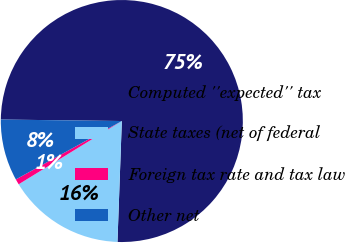Convert chart to OTSL. <chart><loc_0><loc_0><loc_500><loc_500><pie_chart><fcel>Computed ''expected'' tax<fcel>State taxes (net of federal<fcel>Foreign tax rate and tax law<fcel>Other net<nl><fcel>75.38%<fcel>15.67%<fcel>0.74%<fcel>8.21%<nl></chart> 